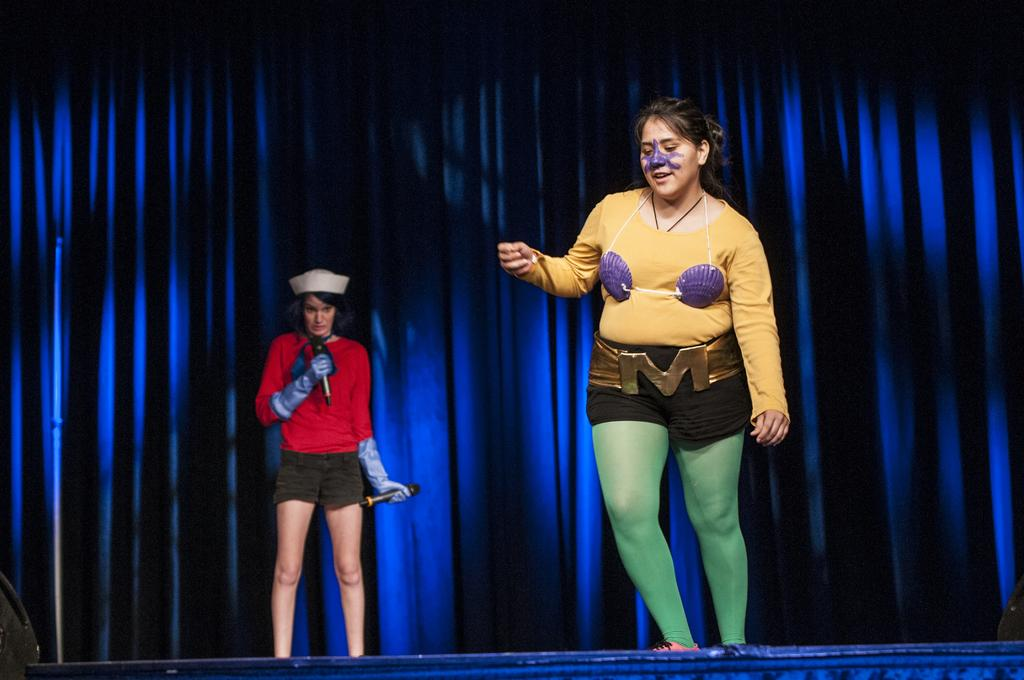What is happening in the image? There are two persons standing on a stage. What is the woman holding in the image? The woman is holding two mics. What can be seen in the background of the image? There is a curtain in the background. How many pigs are visible on the stage in the image? There are no pigs visible on the stage in the image. What grade is the woman teaching in the image? The image does not depict a classroom or teaching scenario, so it is not possible to determine a grade. 